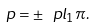Convert formula to latex. <formula><loc_0><loc_0><loc_500><loc_500>p = \pm \ p l _ { 1 } \pi .</formula> 